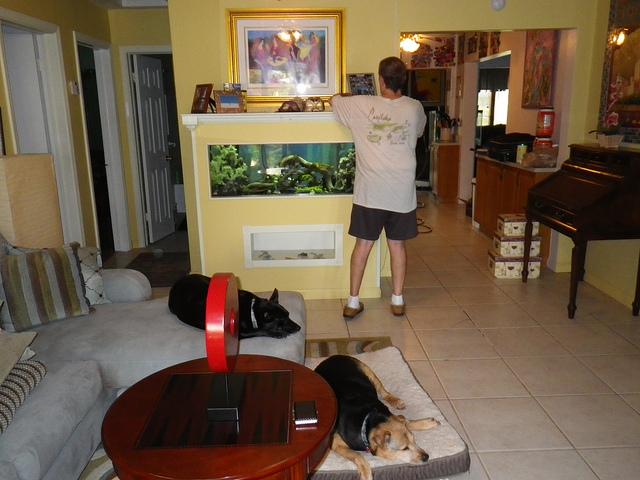Are the two dogs beagles?
Answer briefly. No. What kind of flooring?
Keep it brief. Tile. What is the red object on the round wooden table?
Quick response, please. Clock. 